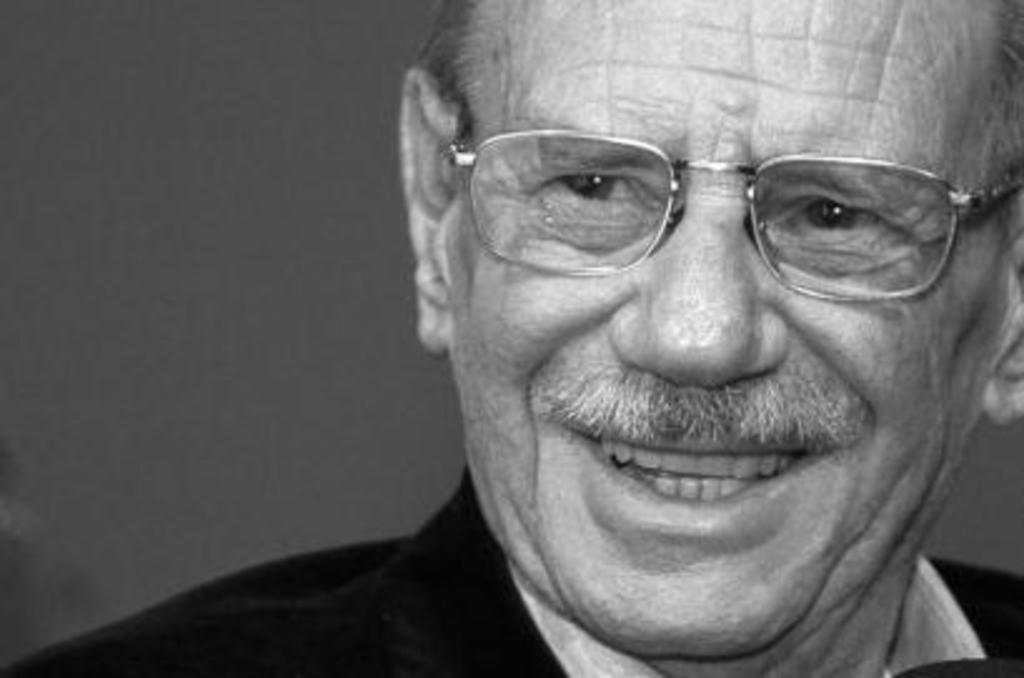What is the color scheme of the image? The image is black and white. Who is present in the image? There is a man in the image. What is the man wearing? The man is wearing spectacles. What is the man's facial expression? The man is smiling. How many eggs are present in the image? There are no eggs present in the image. What type of power is being generated by the man in the image? The man in the image is not generating any power; he is simply smiling. 